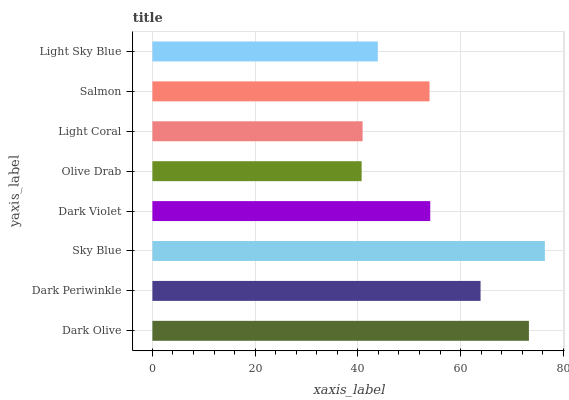Is Olive Drab the minimum?
Answer yes or no. Yes. Is Sky Blue the maximum?
Answer yes or no. Yes. Is Dark Periwinkle the minimum?
Answer yes or no. No. Is Dark Periwinkle the maximum?
Answer yes or no. No. Is Dark Olive greater than Dark Periwinkle?
Answer yes or no. Yes. Is Dark Periwinkle less than Dark Olive?
Answer yes or no. Yes. Is Dark Periwinkle greater than Dark Olive?
Answer yes or no. No. Is Dark Olive less than Dark Periwinkle?
Answer yes or no. No. Is Dark Violet the high median?
Answer yes or no. Yes. Is Salmon the low median?
Answer yes or no. Yes. Is Sky Blue the high median?
Answer yes or no. No. Is Dark Periwinkle the low median?
Answer yes or no. No. 